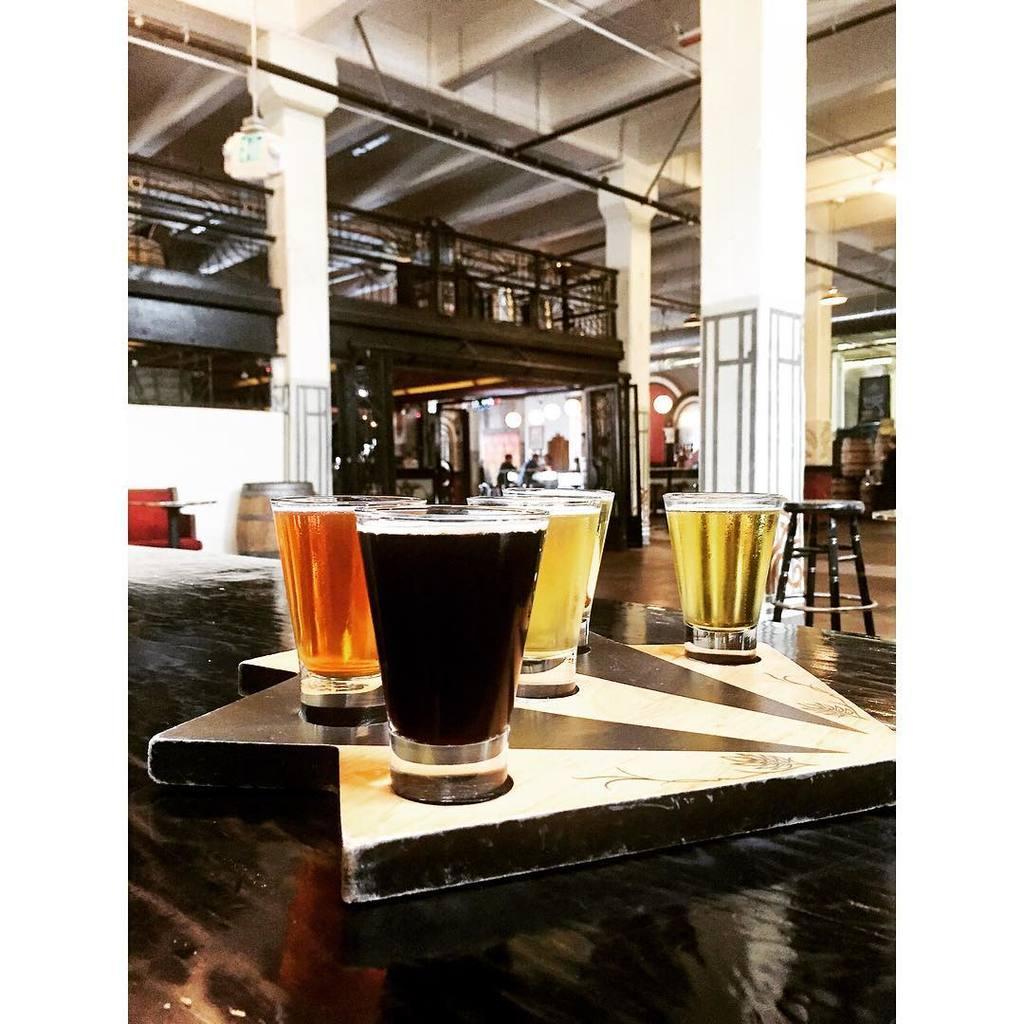Describe this image in one or two sentences. These are the glasses with the wine. 